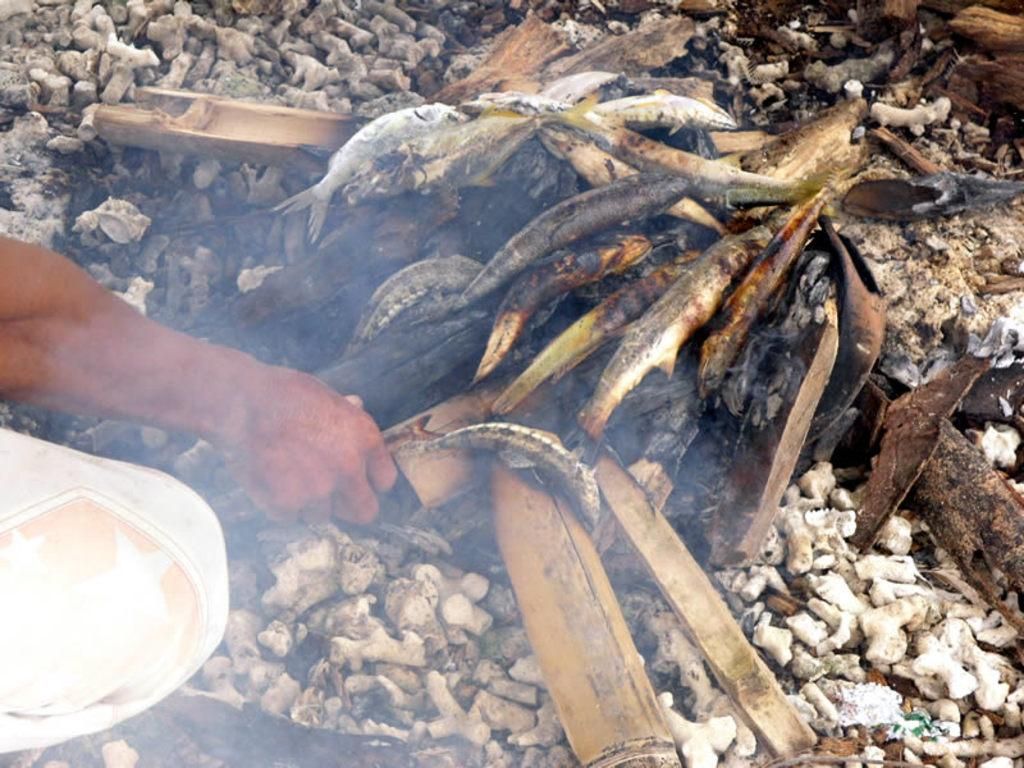What is the person in the image doing? The person is cooking fish. How is the fish being cooked? The fish is being cooked on bamboo sticks. What type of watch is the person wearing while cooking the fish? There is no watch visible in the image, and the person's attire is not mentioned in the provided facts. 